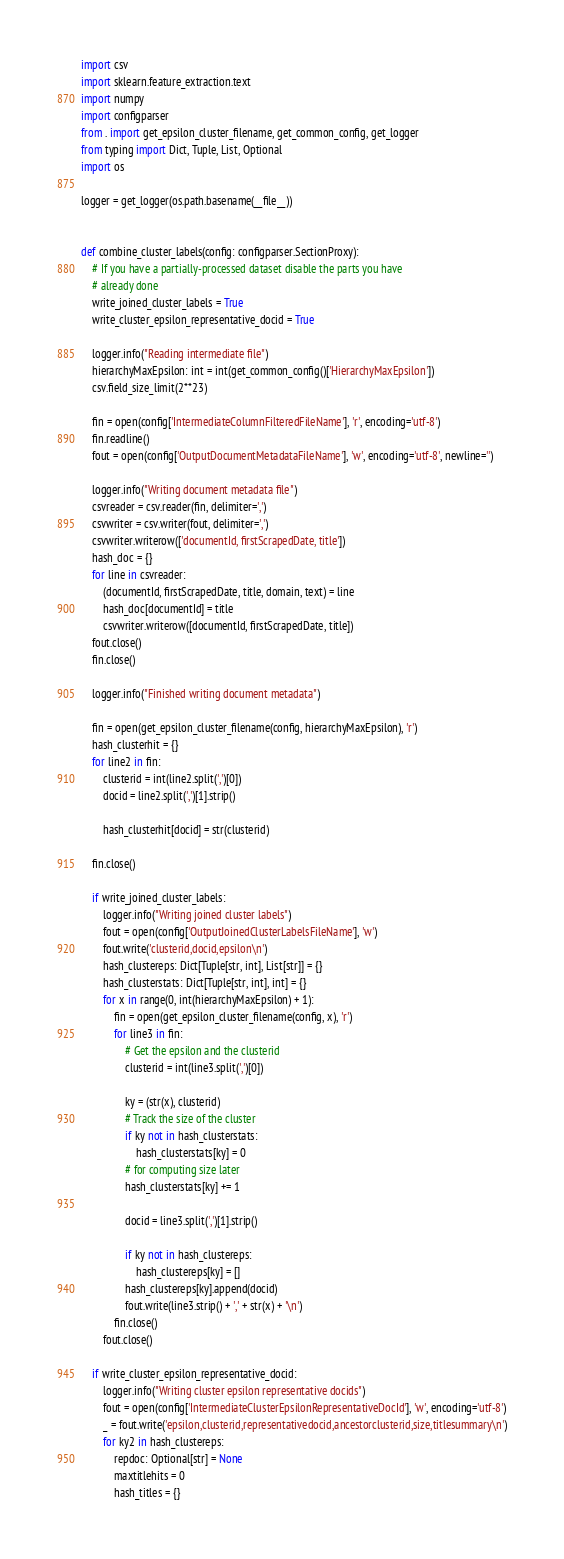Convert code to text. <code><loc_0><loc_0><loc_500><loc_500><_Python_>import csv
import sklearn.feature_extraction.text
import numpy
import configparser
from . import get_epsilon_cluster_filename, get_common_config, get_logger
from typing import Dict, Tuple, List, Optional
import os

logger = get_logger(os.path.basename(__file__))


def combine_cluster_labels(config: configparser.SectionProxy):
    # If you have a partially-processed dataset disable the parts you have
    # already done
    write_joined_cluster_labels = True
    write_cluster_epsilon_representative_docid = True

    logger.info("Reading intermediate file")
    hierarchyMaxEpsilon: int = int(get_common_config()['HierarchyMaxEpsilon'])
    csv.field_size_limit(2**23)

    fin = open(config['IntermediateColumnFilteredFileName'], 'r', encoding='utf-8')
    fin.readline()
    fout = open(config['OutputDocumentMetadataFileName'], 'w', encoding='utf-8', newline='')

    logger.info("Writing document metadata file")
    csvreader = csv.reader(fin, delimiter=',')
    csvwriter = csv.writer(fout, delimiter=',')
    csvwriter.writerow(['documentId, firstScrapedDate, title'])
    hash_doc = {}
    for line in csvreader:
        (documentId, firstScrapedDate, title, domain, text) = line
        hash_doc[documentId] = title
        csvwriter.writerow([documentId, firstScrapedDate, title])
    fout.close()
    fin.close()

    logger.info("Finished writing document metadata")

    fin = open(get_epsilon_cluster_filename(config, hierarchyMaxEpsilon), 'r')
    hash_clusterhit = {}
    for line2 in fin:
        clusterid = int(line2.split(',')[0])
        docid = line2.split(',')[1].strip()

        hash_clusterhit[docid] = str(clusterid)

    fin.close()

    if write_joined_cluster_labels:
        logger.info("Writing joined cluster labels")
        fout = open(config['OutputJoinedClusterLabelsFileName'], 'w')
        fout.write('clusterid,docid,epsilon\n')
        hash_clustereps: Dict[Tuple[str, int], List[str]] = {}
        hash_clusterstats: Dict[Tuple[str, int], int] = {}
        for x in range(0, int(hierarchyMaxEpsilon) + 1):
            fin = open(get_epsilon_cluster_filename(config, x), 'r')
            for line3 in fin:
                # Get the epsilon and the clusterid
                clusterid = int(line3.split(',')[0])

                ky = (str(x), clusterid)
                # Track the size of the cluster
                if ky not in hash_clusterstats:
                    hash_clusterstats[ky] = 0
                # for computing size later
                hash_clusterstats[ky] += 1

                docid = line3.split(',')[1].strip()

                if ky not in hash_clustereps:
                    hash_clustereps[ky] = []
                hash_clustereps[ky].append(docid)
                fout.write(line3.strip() + ',' + str(x) + '\n')
            fin.close()
        fout.close()

    if write_cluster_epsilon_representative_docid:
        logger.info("Writing cluster epsilon representative docids")
        fout = open(config['IntermediateClusterEpsilonRepresentativeDocId'], 'w', encoding='utf-8')
        _ = fout.write('epsilon,clusterid,representativedocid,ancestorclusterid,size,titlesummary\n')
        for ky2 in hash_clustereps:
            repdoc: Optional[str] = None
            maxtitlehits = 0
            hash_titles = {}</code> 